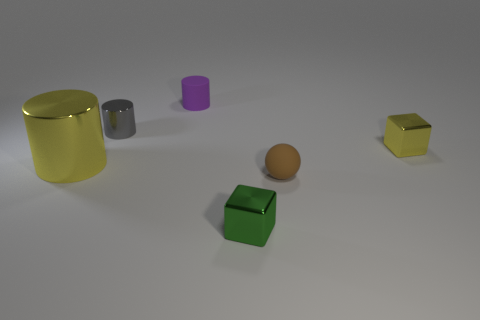What is the color of the big thing that is on the left side of the tiny shiny cylinder?
Your response must be concise. Yellow. Do the large thing and the tiny brown thing have the same shape?
Your response must be concise. No. What color is the object that is both left of the green metal block and in front of the gray shiny cylinder?
Keep it short and to the point. Yellow. Is the size of the yellow metallic object on the right side of the purple object the same as the matte object that is behind the gray shiny object?
Make the answer very short. Yes. What number of things are small things behind the tiny yellow block or yellow metal things?
Ensure brevity in your answer.  4. What is the material of the tiny yellow cube?
Provide a succinct answer. Metal. Does the purple rubber cylinder have the same size as the brown ball?
Provide a short and direct response. Yes. How many cylinders are big matte things or purple rubber objects?
Provide a succinct answer. 1. The tiny cylinder on the left side of the tiny matte object to the left of the green thing is what color?
Make the answer very short. Gray. Are there fewer green blocks that are behind the green object than big metallic cylinders that are in front of the purple matte cylinder?
Provide a succinct answer. Yes. 